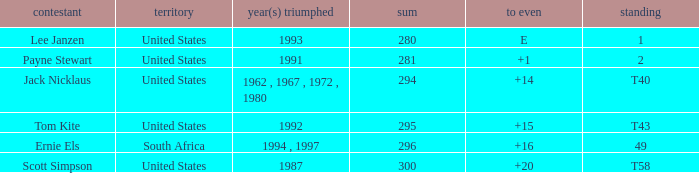What Country is Tom Kite from? United States. 